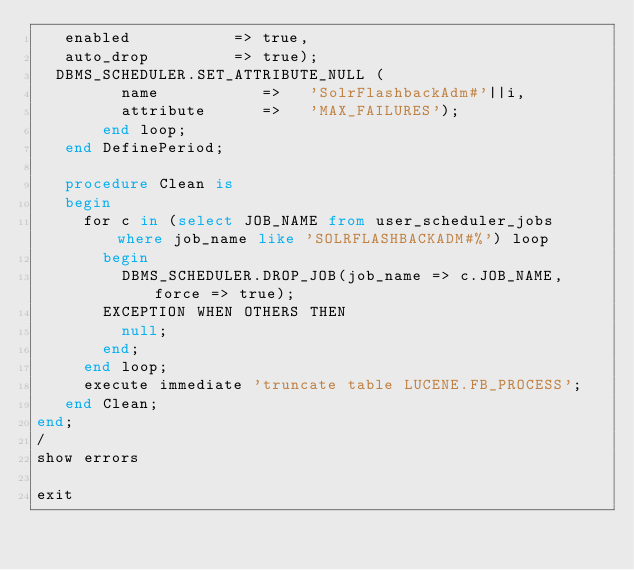<code> <loc_0><loc_0><loc_500><loc_500><_SQL_>   enabled           => true,
   auto_drop         => true);
  DBMS_SCHEDULER.SET_ATTRIBUTE_NULL (
         name           =>   'SolrFlashbackAdm#'||i,
         attribute      =>   'MAX_FAILURES');
       end loop;
   end DefinePeriod;

   procedure Clean is
   begin
     for c in (select JOB_NAME from user_scheduler_jobs where job_name like 'SOLRFLASHBACKADM#%') loop
       begin
         DBMS_SCHEDULER.DROP_JOB(job_name => c.JOB_NAME, force => true);
       EXCEPTION WHEN OTHERS THEN
         null;
       end;
     end loop;
     execute immediate 'truncate table LUCENE.FB_PROCESS';
   end Clean;
end;
/
show errors

exit
</code> 